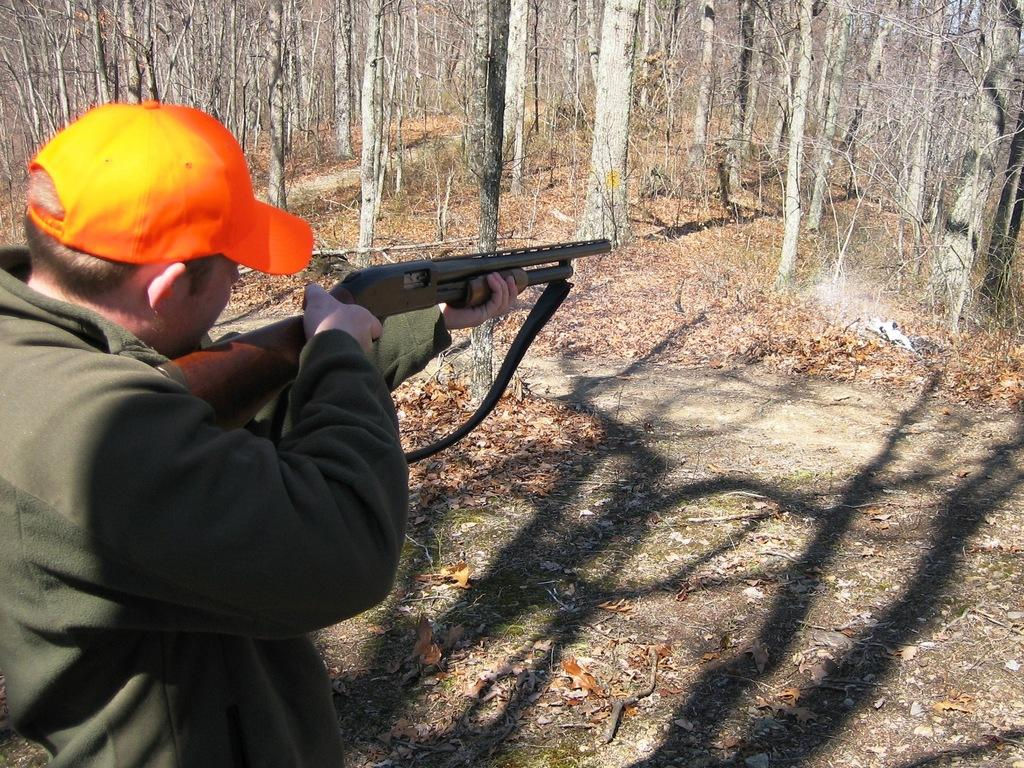What is the main subject of the image? There is a person in the image. What is the person holding in the image? The person is holding a gun. What action is the person performing with the gun? The person is shooting in front of them. What type of natural environment can be seen in the image? There are trees visible in the image. How many sisters are present in the image? There is no mention of sisters in the image, as it features a person holding a gun and shooting in front of them. What type of coal can be seen in the image? There is no coal present in the image. 